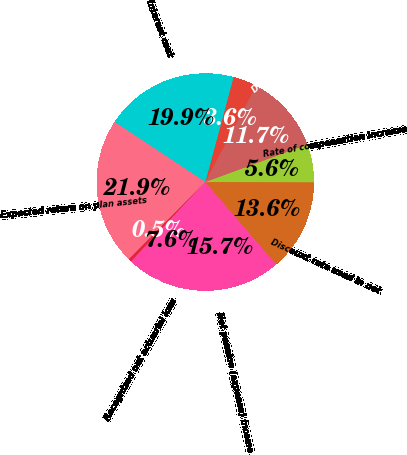<chart> <loc_0><loc_0><loc_500><loc_500><pie_chart><fcel>Service cost<fcel>Interest cost<fcel>Expected return on plan assets<fcel>Amortization of prior service<fcel>Recognized net actuarial loss<fcel>Net pension (expense) income<fcel>Discount rate used in net<fcel>Rate of compensation increase<fcel>Discount rate used in benefit<nl><fcel>3.56%<fcel>19.88%<fcel>21.88%<fcel>0.45%<fcel>7.64%<fcel>15.65%<fcel>13.65%<fcel>5.64%<fcel>11.65%<nl></chart> 